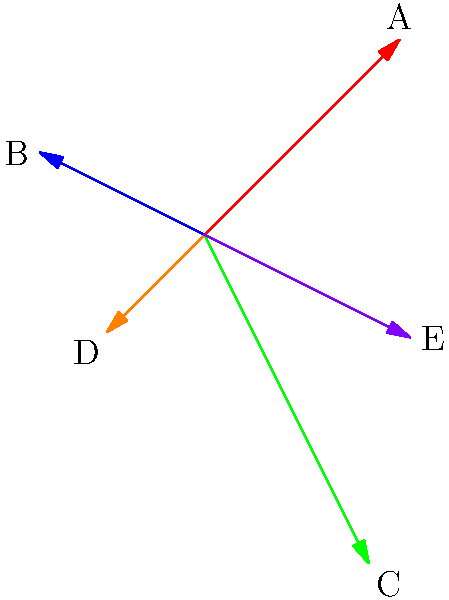Look at the colorful arrows in the picture. Which arrow is the longest? To find the longest arrow, we need to compare the lengths of all the arrows:

1. First, let's identify each arrow:
   - Red arrow (A)
   - Blue arrow (B)
   - Green arrow (C)
   - Orange arrow (D)
   - Purple arrow (E)

2. Now, let's compare their lengths visually:
   - The green arrow (C) appears to be the longest.
   - The red arrow (A) is the second longest.
   - The purple arrow (E) is the third longest.
   - The blue arrow (B) is the fourth longest.
   - The orange arrow (D) is the shortest.

3. We can clearly see that the green arrow (C) extends further than all other arrows.

Therefore, the longest arrow is the green arrow, labeled as C.
Answer: C (Green arrow) 